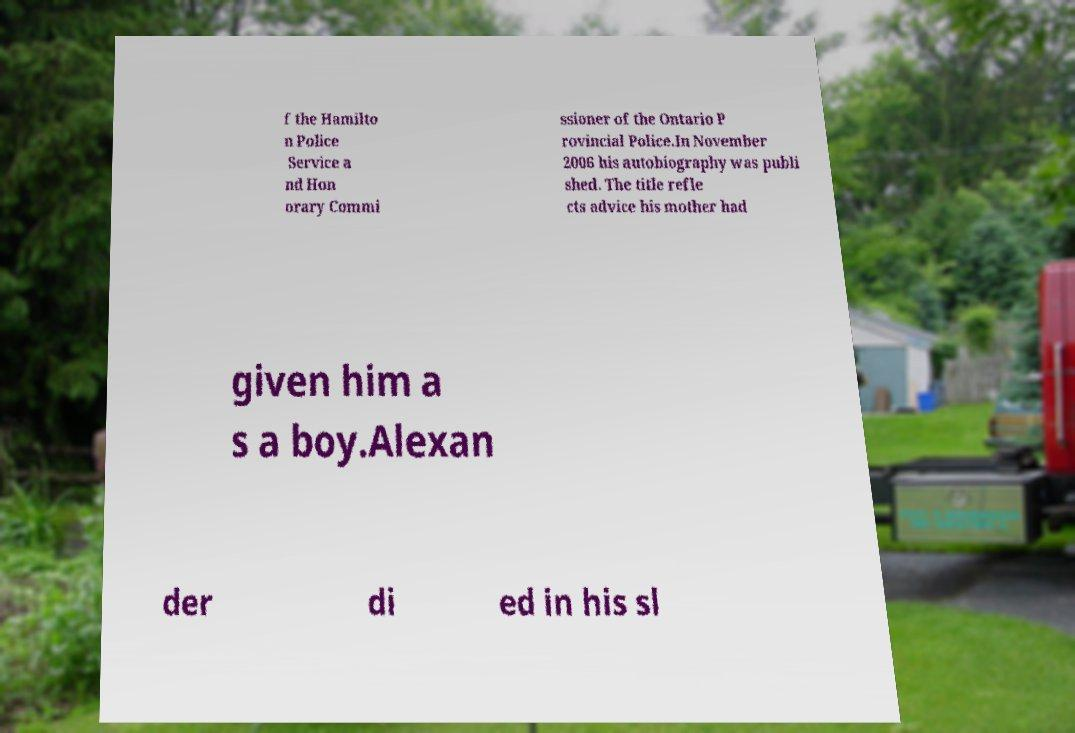Can you read and provide the text displayed in the image?This photo seems to have some interesting text. Can you extract and type it out for me? f the Hamilto n Police Service a nd Hon orary Commi ssioner of the Ontario P rovincial Police.In November 2006 his autobiography was publi shed. The title refle cts advice his mother had given him a s a boy.Alexan der di ed in his sl 